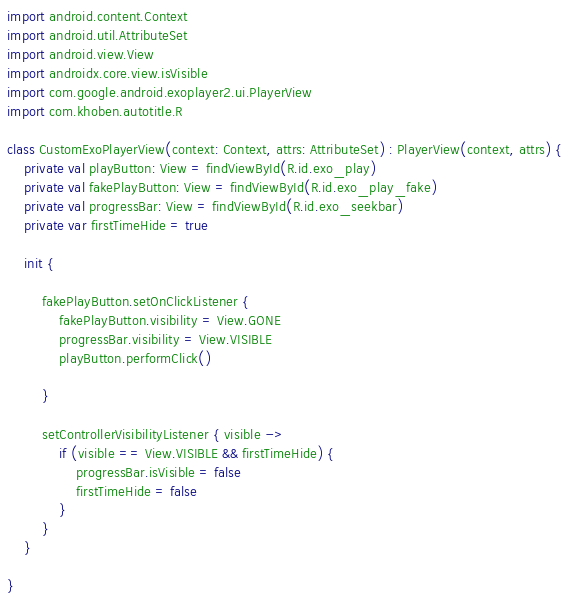<code> <loc_0><loc_0><loc_500><loc_500><_Kotlin_>import android.content.Context
import android.util.AttributeSet
import android.view.View
import androidx.core.view.isVisible
import com.google.android.exoplayer2.ui.PlayerView
import com.khoben.autotitle.R

class CustomExoPlayerView(context: Context, attrs: AttributeSet) : PlayerView(context, attrs) {
    private val playButton: View = findViewById(R.id.exo_play)
    private val fakePlayButton: View = findViewById(R.id.exo_play_fake)
    private val progressBar: View = findViewById(R.id.exo_seekbar)
    private var firstTimeHide = true

    init {

        fakePlayButton.setOnClickListener {
            fakePlayButton.visibility = View.GONE
            progressBar.visibility = View.VISIBLE
            playButton.performClick()

        }

        setControllerVisibilityListener { visible ->
            if (visible == View.VISIBLE && firstTimeHide) {
                progressBar.isVisible = false
                firstTimeHide = false
            }
        }
    }

}</code> 